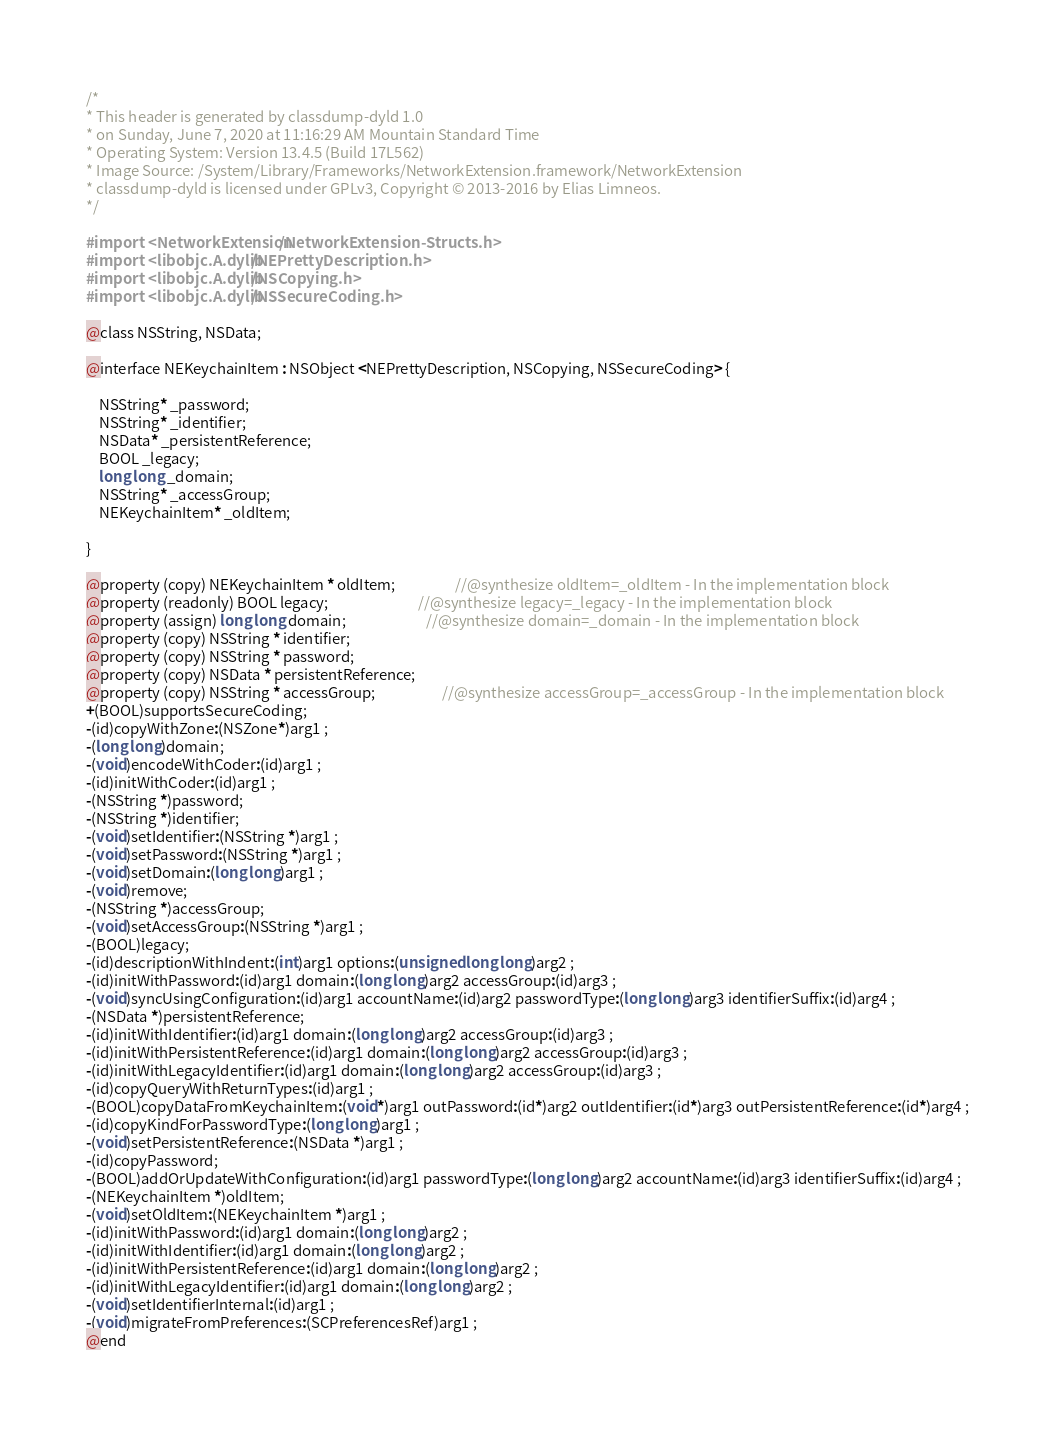Convert code to text. <code><loc_0><loc_0><loc_500><loc_500><_C_>/*
* This header is generated by classdump-dyld 1.0
* on Sunday, June 7, 2020 at 11:16:29 AM Mountain Standard Time
* Operating System: Version 13.4.5 (Build 17L562)
* Image Source: /System/Library/Frameworks/NetworkExtension.framework/NetworkExtension
* classdump-dyld is licensed under GPLv3, Copyright © 2013-2016 by Elias Limneos.
*/

#import <NetworkExtension/NetworkExtension-Structs.h>
#import <libobjc.A.dylib/NEPrettyDescription.h>
#import <libobjc.A.dylib/NSCopying.h>
#import <libobjc.A.dylib/NSSecureCoding.h>

@class NSString, NSData;

@interface NEKeychainItem : NSObject <NEPrettyDescription, NSCopying, NSSecureCoding> {

	NSString* _password;
	NSString* _identifier;
	NSData* _persistentReference;
	BOOL _legacy;
	long long _domain;
	NSString* _accessGroup;
	NEKeychainItem* _oldItem;

}

@property (copy) NEKeychainItem * oldItem;                  //@synthesize oldItem=_oldItem - In the implementation block
@property (readonly) BOOL legacy;                           //@synthesize legacy=_legacy - In the implementation block
@property (assign) long long domain;                        //@synthesize domain=_domain - In the implementation block
@property (copy) NSString * identifier; 
@property (copy) NSString * password; 
@property (copy) NSData * persistentReference; 
@property (copy) NSString * accessGroup;                    //@synthesize accessGroup=_accessGroup - In the implementation block
+(BOOL)supportsSecureCoding;
-(id)copyWithZone:(NSZone*)arg1 ;
-(long long)domain;
-(void)encodeWithCoder:(id)arg1 ;
-(id)initWithCoder:(id)arg1 ;
-(NSString *)password;
-(NSString *)identifier;
-(void)setIdentifier:(NSString *)arg1 ;
-(void)setPassword:(NSString *)arg1 ;
-(void)setDomain:(long long)arg1 ;
-(void)remove;
-(NSString *)accessGroup;
-(void)setAccessGroup:(NSString *)arg1 ;
-(BOOL)legacy;
-(id)descriptionWithIndent:(int)arg1 options:(unsigned long long)arg2 ;
-(id)initWithPassword:(id)arg1 domain:(long long)arg2 accessGroup:(id)arg3 ;
-(void)syncUsingConfiguration:(id)arg1 accountName:(id)arg2 passwordType:(long long)arg3 identifierSuffix:(id)arg4 ;
-(NSData *)persistentReference;
-(id)initWithIdentifier:(id)arg1 domain:(long long)arg2 accessGroup:(id)arg3 ;
-(id)initWithPersistentReference:(id)arg1 domain:(long long)arg2 accessGroup:(id)arg3 ;
-(id)initWithLegacyIdentifier:(id)arg1 domain:(long long)arg2 accessGroup:(id)arg3 ;
-(id)copyQueryWithReturnTypes:(id)arg1 ;
-(BOOL)copyDataFromKeychainItem:(void*)arg1 outPassword:(id*)arg2 outIdentifier:(id*)arg3 outPersistentReference:(id*)arg4 ;
-(id)copyKindForPasswordType:(long long)arg1 ;
-(void)setPersistentReference:(NSData *)arg1 ;
-(id)copyPassword;
-(BOOL)addOrUpdateWithConfiguration:(id)arg1 passwordType:(long long)arg2 accountName:(id)arg3 identifierSuffix:(id)arg4 ;
-(NEKeychainItem *)oldItem;
-(void)setOldItem:(NEKeychainItem *)arg1 ;
-(id)initWithPassword:(id)arg1 domain:(long long)arg2 ;
-(id)initWithIdentifier:(id)arg1 domain:(long long)arg2 ;
-(id)initWithPersistentReference:(id)arg1 domain:(long long)arg2 ;
-(id)initWithLegacyIdentifier:(id)arg1 domain:(long long)arg2 ;
-(void)setIdentifierInternal:(id)arg1 ;
-(void)migrateFromPreferences:(SCPreferencesRef)arg1 ;
@end

</code> 